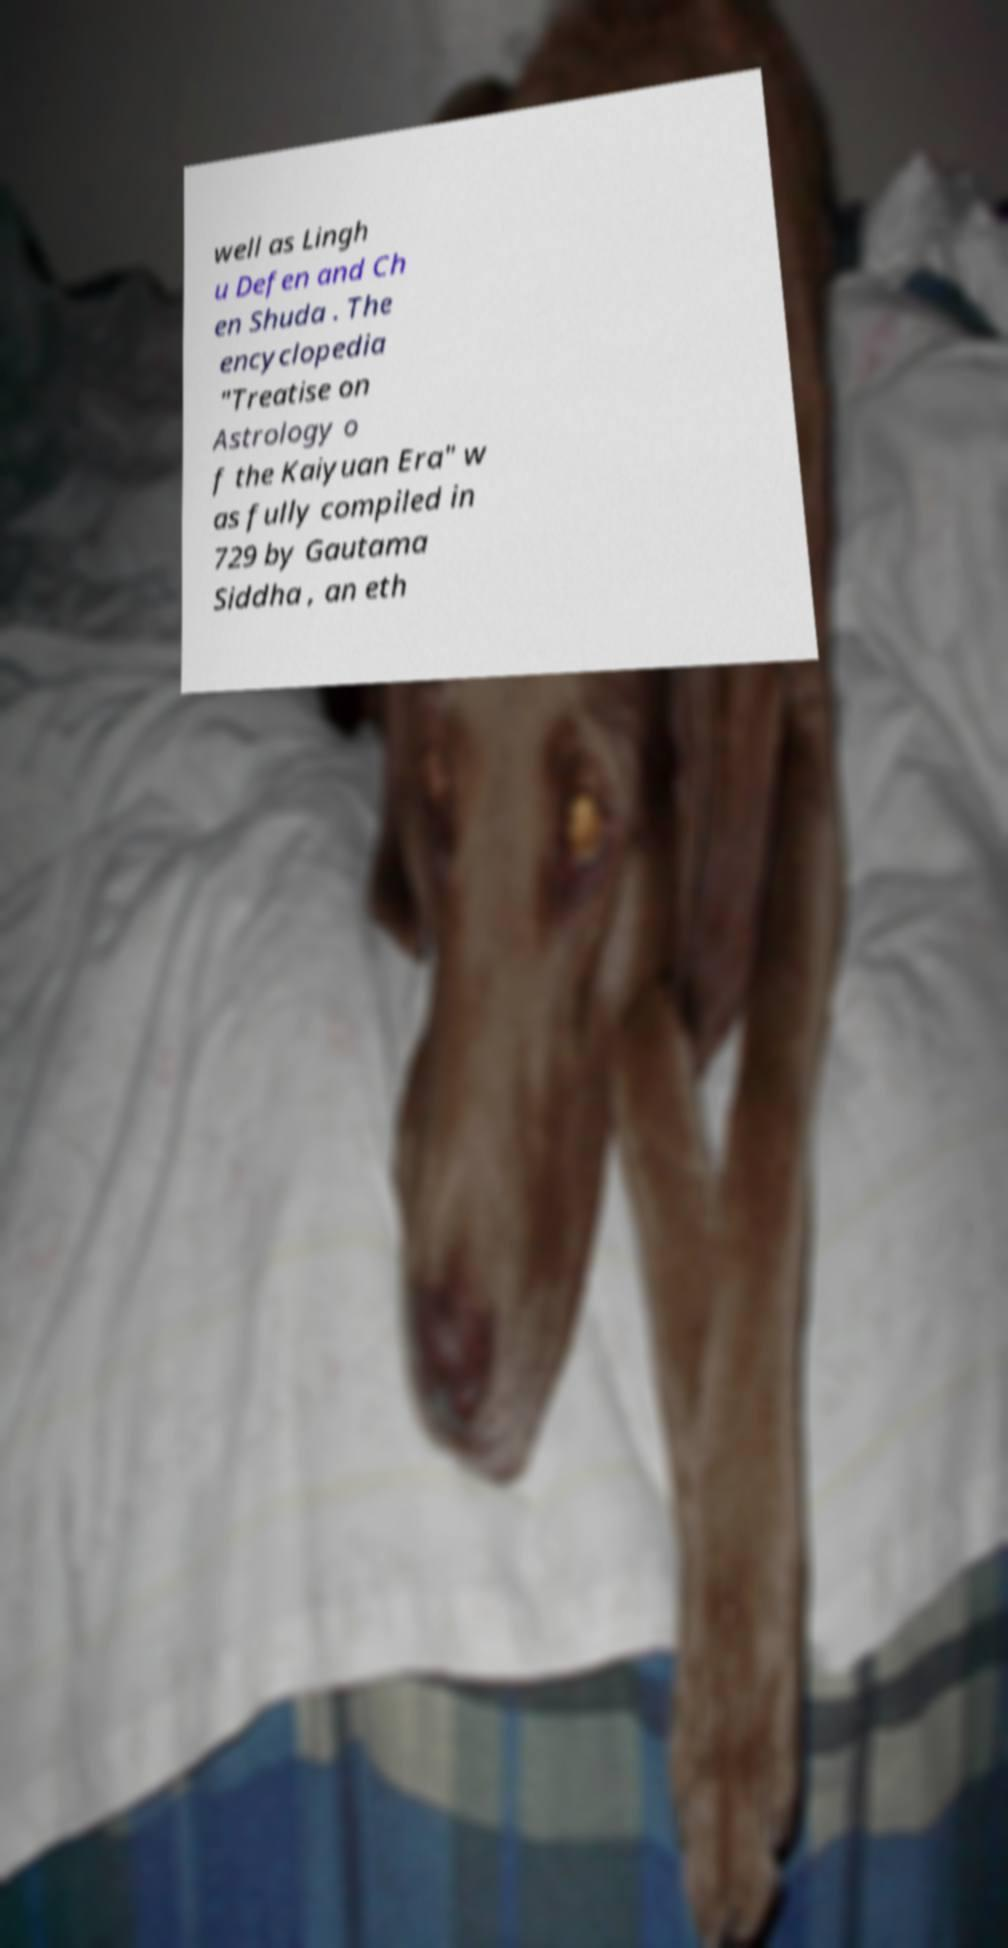What messages or text are displayed in this image? I need them in a readable, typed format. well as Lingh u Defen and Ch en Shuda . The encyclopedia "Treatise on Astrology o f the Kaiyuan Era" w as fully compiled in 729 by Gautama Siddha , an eth 